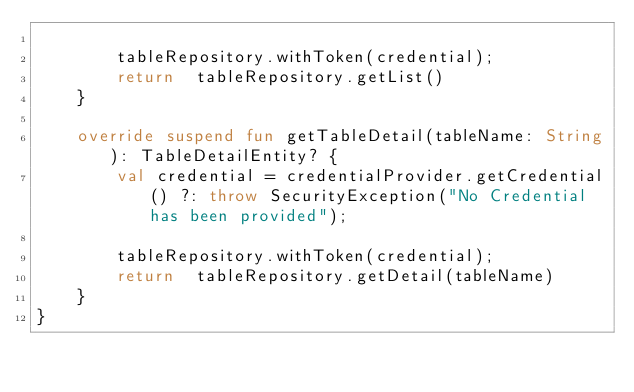<code> <loc_0><loc_0><loc_500><loc_500><_Kotlin_>
        tableRepository.withToken(credential);
        return  tableRepository.getList()
    }

    override suspend fun getTableDetail(tableName: String): TableDetailEntity? {
        val credential = credentialProvider.getCredential() ?: throw SecurityException("No Credential has been provided");

        tableRepository.withToken(credential);
        return  tableRepository.getDetail(tableName)
    }
}</code> 